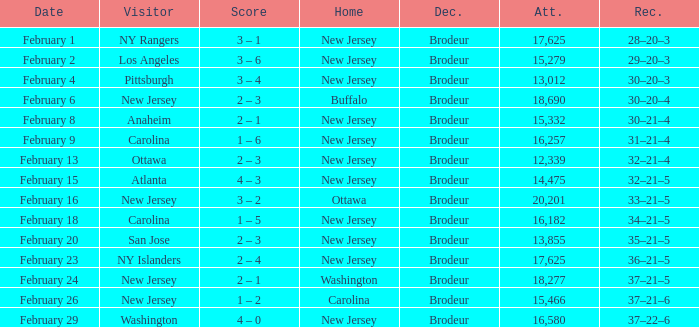What was the score when the NY Islanders was the visiting team? 2 – 4. 